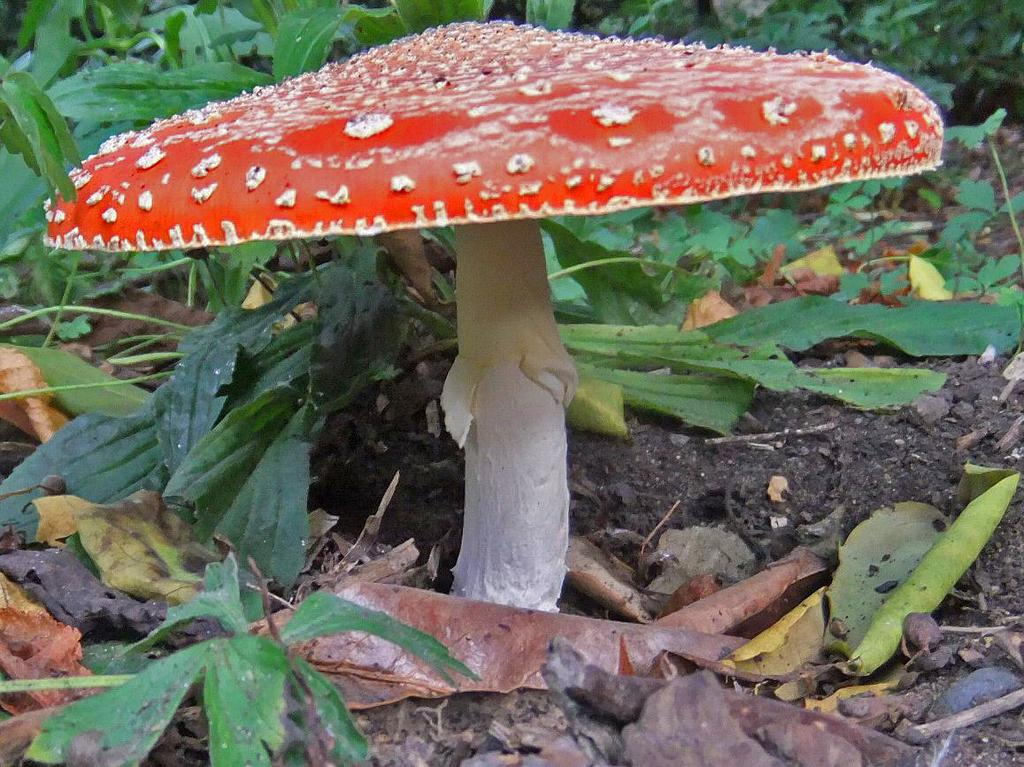What color is the mushroom on the ground in the image? The mushroom on the ground is orange in color. What else can be seen on the ground in the image? There are dry leaves and stones on the ground in the image. What is visible in the background of the image? In the background, there are plants on the ground. What instrument is the mushroom playing in the image? There is no instrument present in the image, and the mushroom is not playing any instrument. 